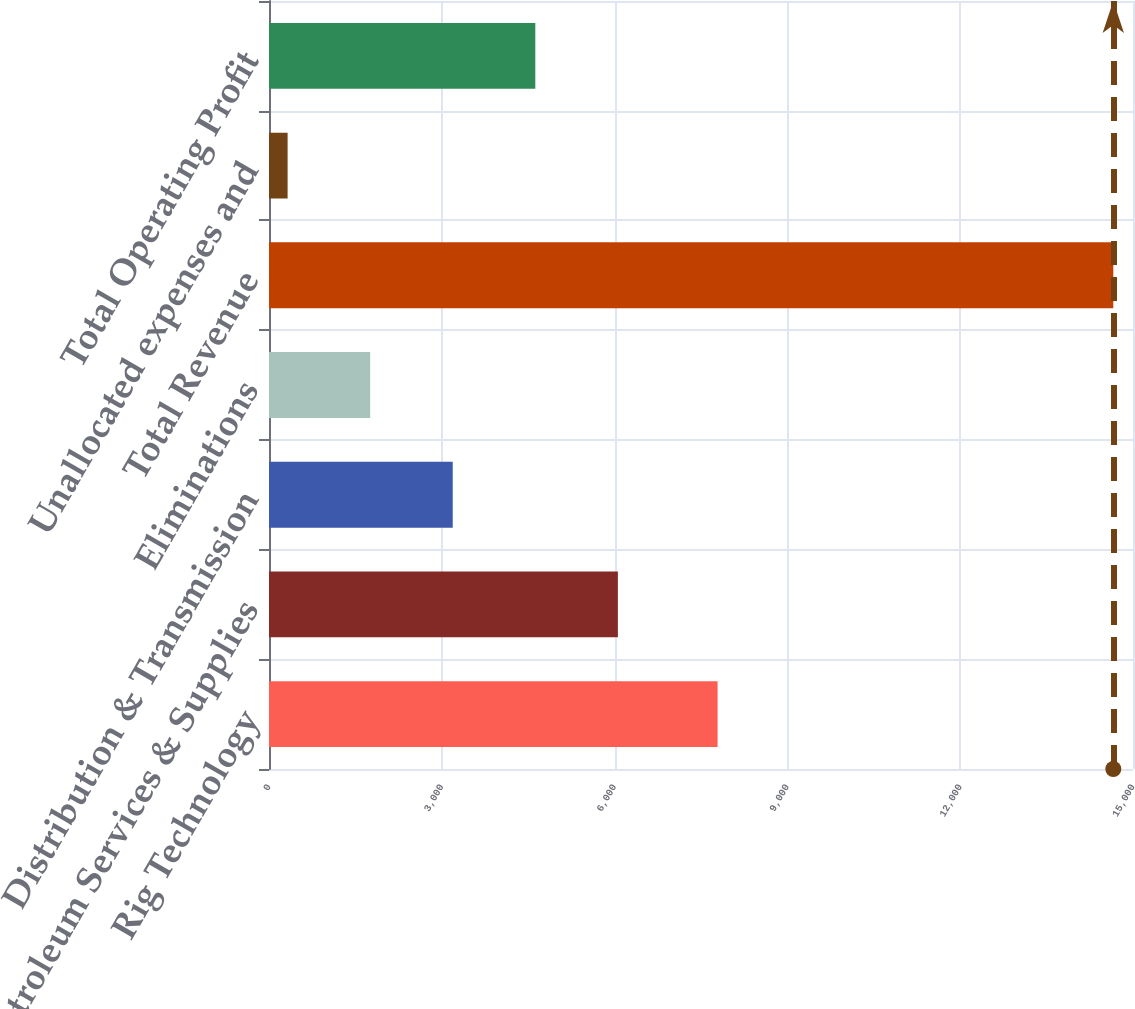Convert chart to OTSL. <chart><loc_0><loc_0><loc_500><loc_500><bar_chart><fcel>Rig Technology<fcel>Petroleum Services & Supplies<fcel>Distribution & Transmission<fcel>Eliminations<fcel>Total Revenue<fcel>Unallocated expenses and<fcel>Total Operating Profit<nl><fcel>7788<fcel>6057<fcel>3190<fcel>1756.5<fcel>14658<fcel>323<fcel>4623.5<nl></chart> 